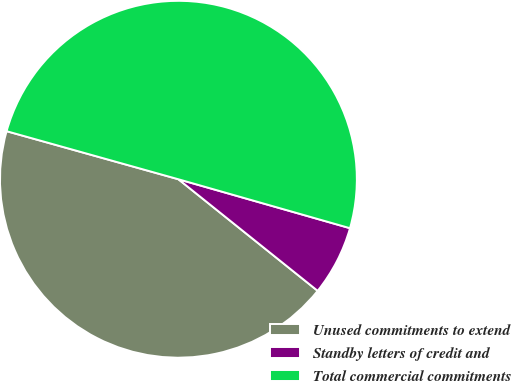<chart> <loc_0><loc_0><loc_500><loc_500><pie_chart><fcel>Unused commitments to extend<fcel>Standby letters of credit and<fcel>Total commercial commitments<nl><fcel>43.59%<fcel>6.33%<fcel>50.08%<nl></chart> 